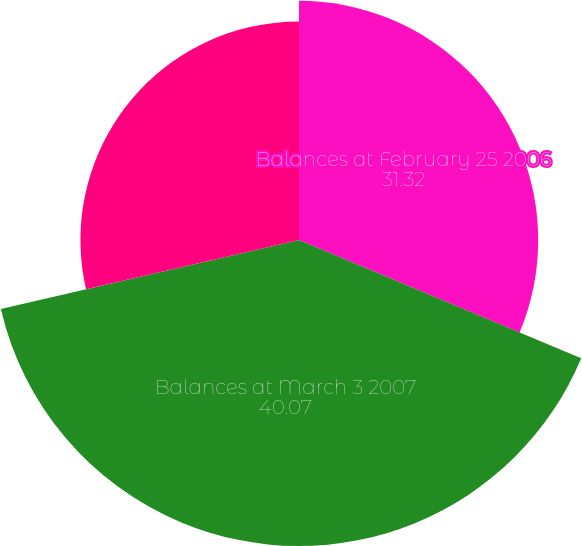Convert chart. <chart><loc_0><loc_0><loc_500><loc_500><pie_chart><fcel>Balances at February 25 2006<fcel>Balances at March 3 2007<fcel>Balances at March 1 2008<nl><fcel>31.32%<fcel>40.07%<fcel>28.62%<nl></chart> 